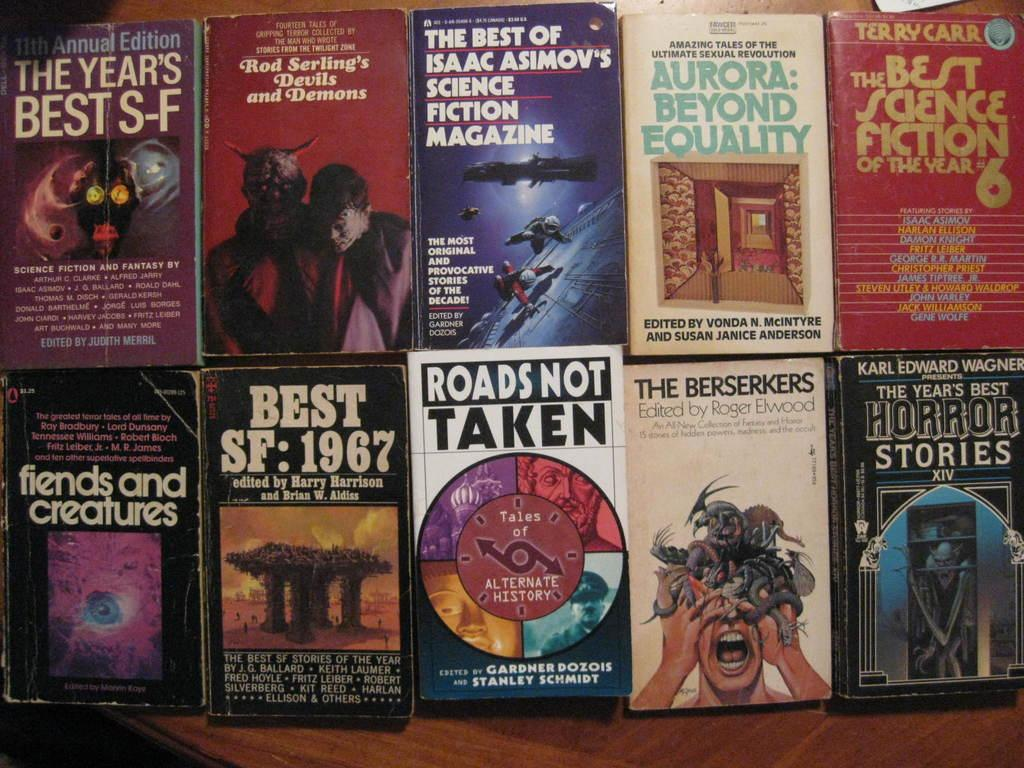Provide a one-sentence caption for the provided image. Several old science fiction books including titles such as ROADS NOT TAKEN and fiends and creatures. 